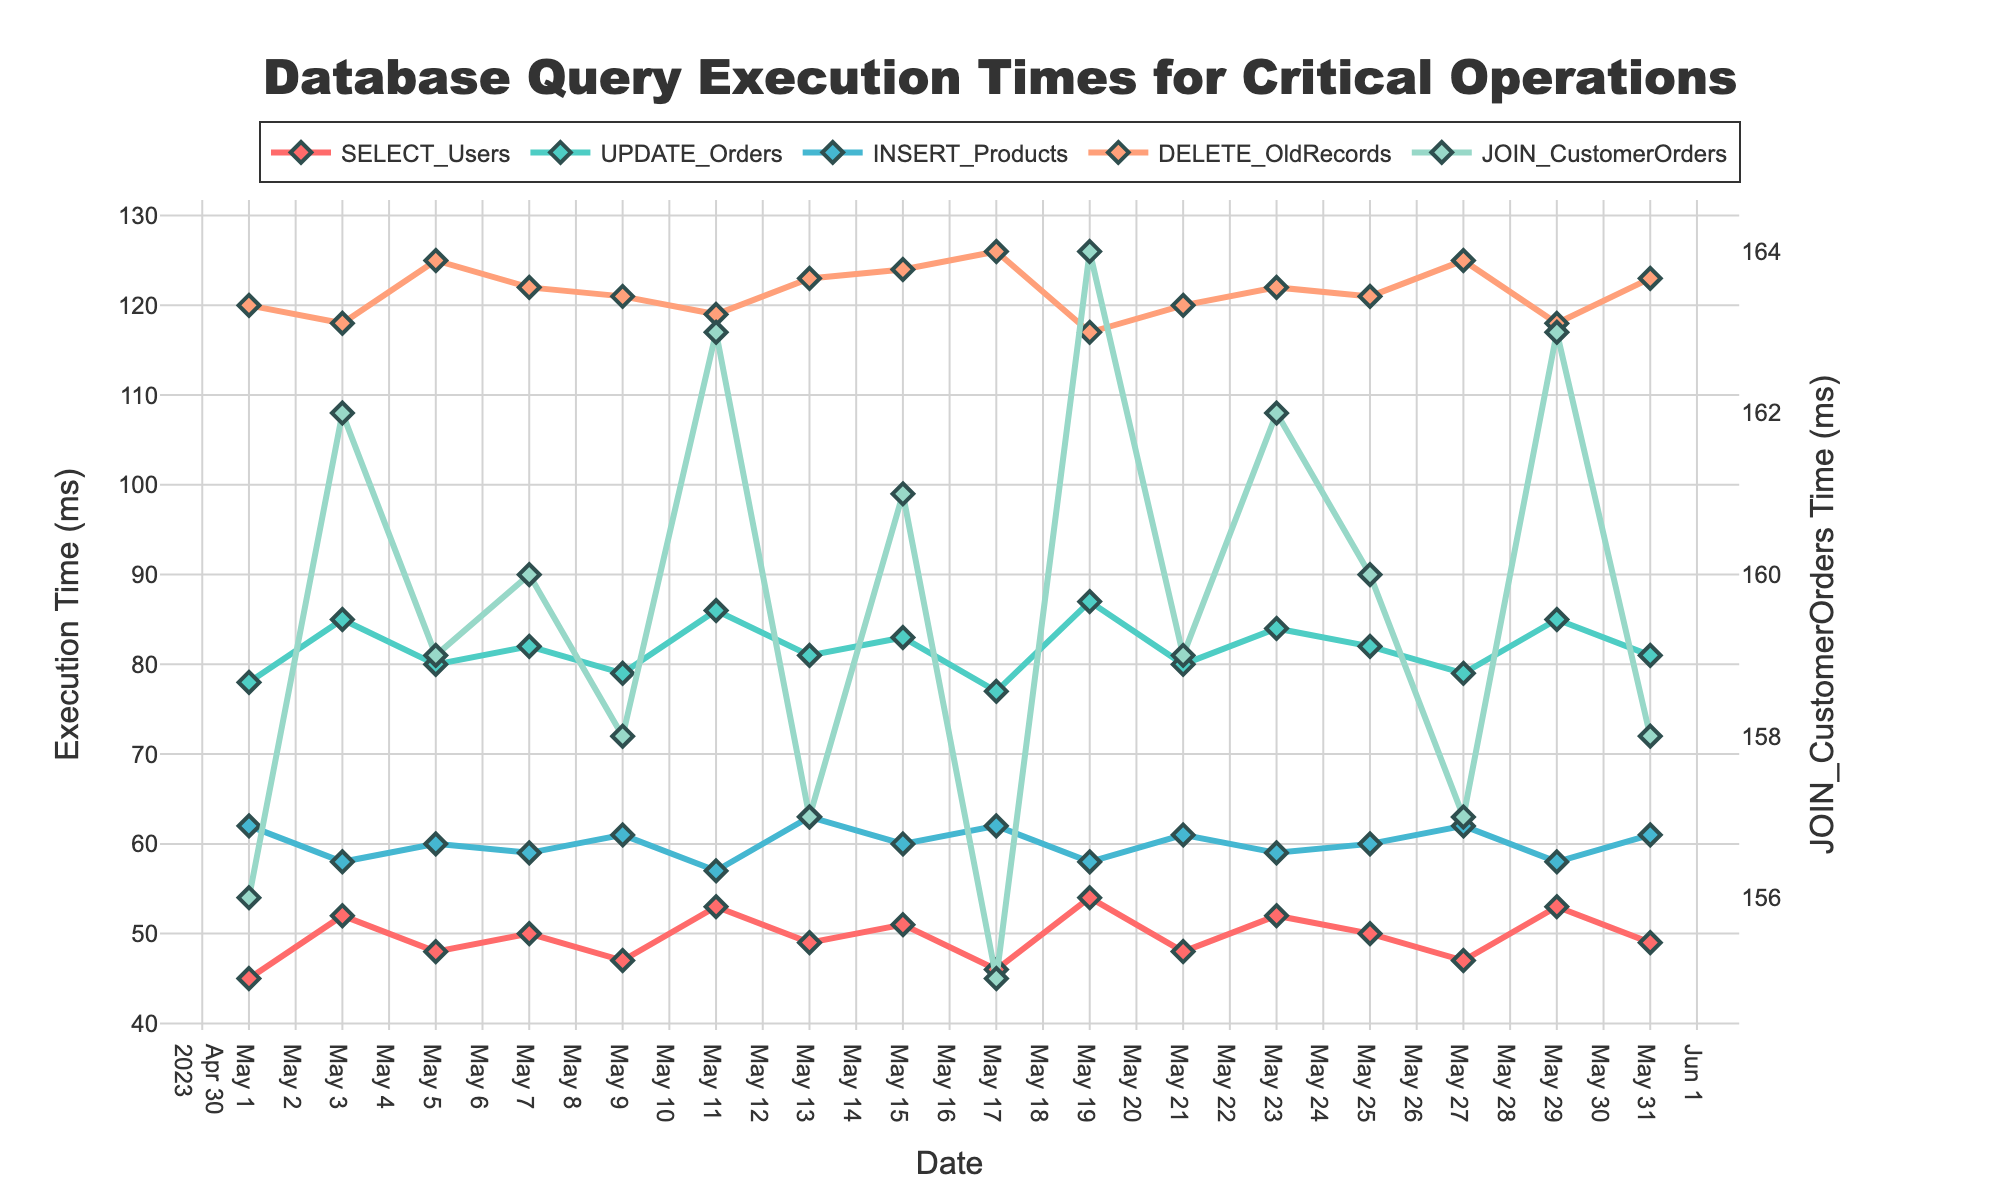What's the trend of 'SELECT_Users' query execution time over the month? The 'SELECT_Users' execution time varies between 45 ms and 54 ms. It starts at 45 ms on May 1, peaks at 54 ms on May 19, and ends at 49 ms on May 31.
Answer: Increasing slightly, peaks on May 19, then stabilizes During which date did 'JOIN_CustomerOrders' have the shortest execution time? By examining the chart, the shortest execution time for 'JOIN_CustomerOrders' is on May 17, where it reaches 155 ms.
Answer: May 17 How does the execution time for 'UPDATE_Orders' on May 21 compare to 'INSERT_Products' on the same day? On May 21, the 'UPDATE_Orders' execution time is 80 ms whereas 'INSERT_Products' is 61 ms. 'UPDATE_Orders' is higher than 'INSERT_Products'.
Answer: 'UPDATE_Orders' is higher Find the average 'DELETE_OldRecords' execution time across all days. Sum the 'DELETE_OldRecords' times and divide by the total number of days: (120+118+125+122+121+119+123+124+126+117+120+122+121+125+118+123)/16 = 121.2 ms.
Answer: 121.2 ms Which query type had the most consistent execution time over the month? By visually inspecting the line chart, 'UPDATE_Orders' appears to have minor fluctuations, ranging from 77 ms to 87 ms, indicating it has the most consistent execution time.
Answer: 'UPDATE_Orders' Compare the highest execution time for 'SELECT_Users' and 'DELETE_OldRecords'. Which one is higher and by how much? The highest 'SELECT_Users' execution time is 54 ms on May 19, and the highest 'DELETE_OldRecords' is 126 ms on May 17. 'DELETE_OldRecords' is higher by 126 - 54 = 72 ms.
Answer: 'DELETE_OldRecords' by 72 ms What is the range of execution times for 'INSERT_Products' throughout the month? The minimum and maximum execution times for 'INSERT_Products' are 57 ms and 63 ms respectively. The range is 63 - 57 = 6 ms.
Answer: 6 ms On which dates do 'JOIN_CustomerOrders' and 'DELETE_OldRecords' queries have the same execution time? By comparing the line chart, 'JOIN_CustomerOrders' and 'DELETE_OldRecords' execution times are both 120 ms on May 1.
Answer: May 1 How does the execution time of 'INSERT_Products' on May 15 compare to its average execution time? The execution time of 'INSERT_Products' on May 15 is 60 ms. The average across all days is (62+58+60+59+61+57+63+60+62+58+61+59+60+62+58+61)/16 = 60.125 ms. 'INSERT_Products' on May 15 is slightly below its average.
Answer: Slightly below 